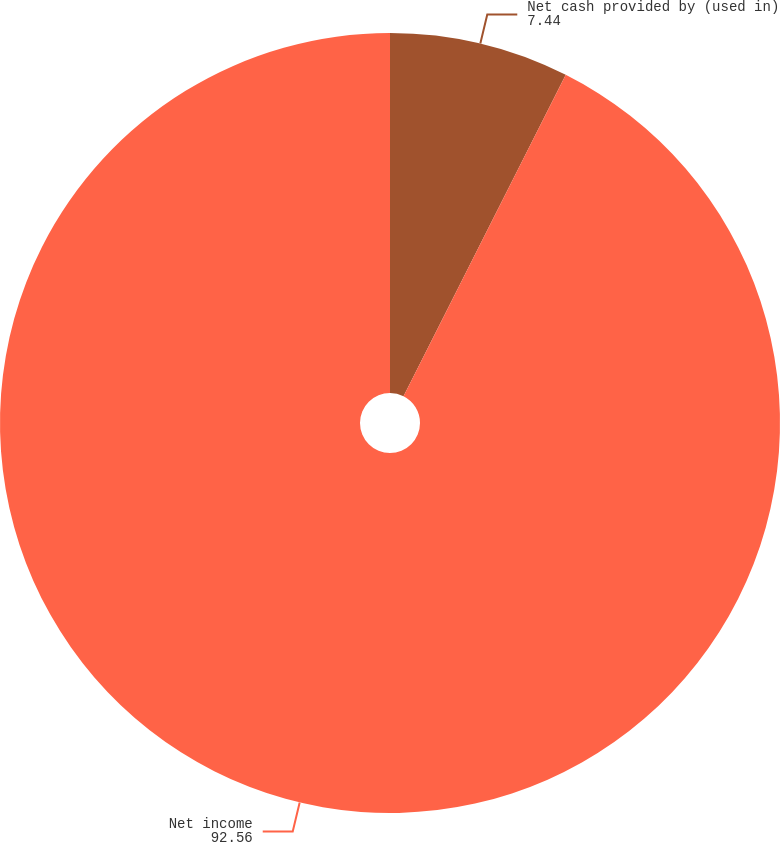<chart> <loc_0><loc_0><loc_500><loc_500><pie_chart><fcel>Net cash provided by (used in)<fcel>Net income<nl><fcel>7.44%<fcel>92.56%<nl></chart> 